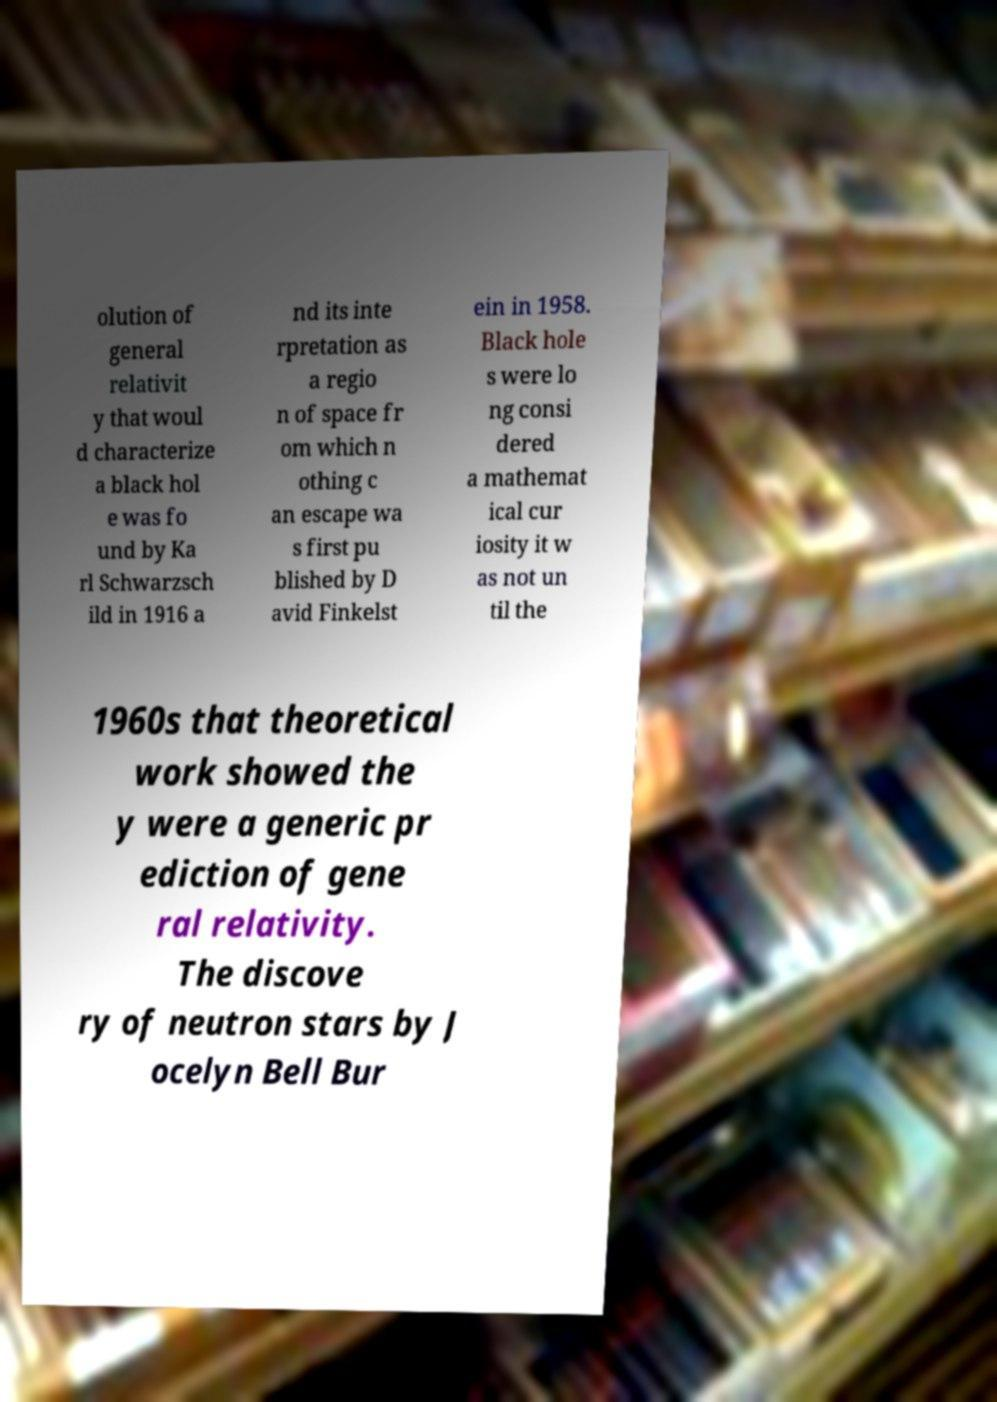Can you accurately transcribe the text from the provided image for me? olution of general relativit y that woul d characterize a black hol e was fo und by Ka rl Schwarzsch ild in 1916 a nd its inte rpretation as a regio n of space fr om which n othing c an escape wa s first pu blished by D avid Finkelst ein in 1958. Black hole s were lo ng consi dered a mathemat ical cur iosity it w as not un til the 1960s that theoretical work showed the y were a generic pr ediction of gene ral relativity. The discove ry of neutron stars by J ocelyn Bell Bur 